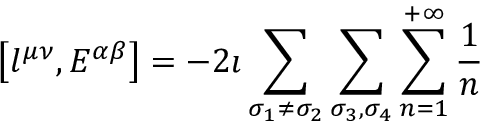Convert formula to latex. <formula><loc_0><loc_0><loc_500><loc_500>\left [ l ^ { \mu \nu } , E ^ { \alpha \beta } \right ] = - 2 \imath \sum _ { \sigma _ { 1 } \neq \sigma _ { 2 } } \sum _ { \sigma _ { 3 } , \sigma _ { 4 } } \sum _ { n = 1 } ^ { + \infty } \frac { 1 } { n }</formula> 